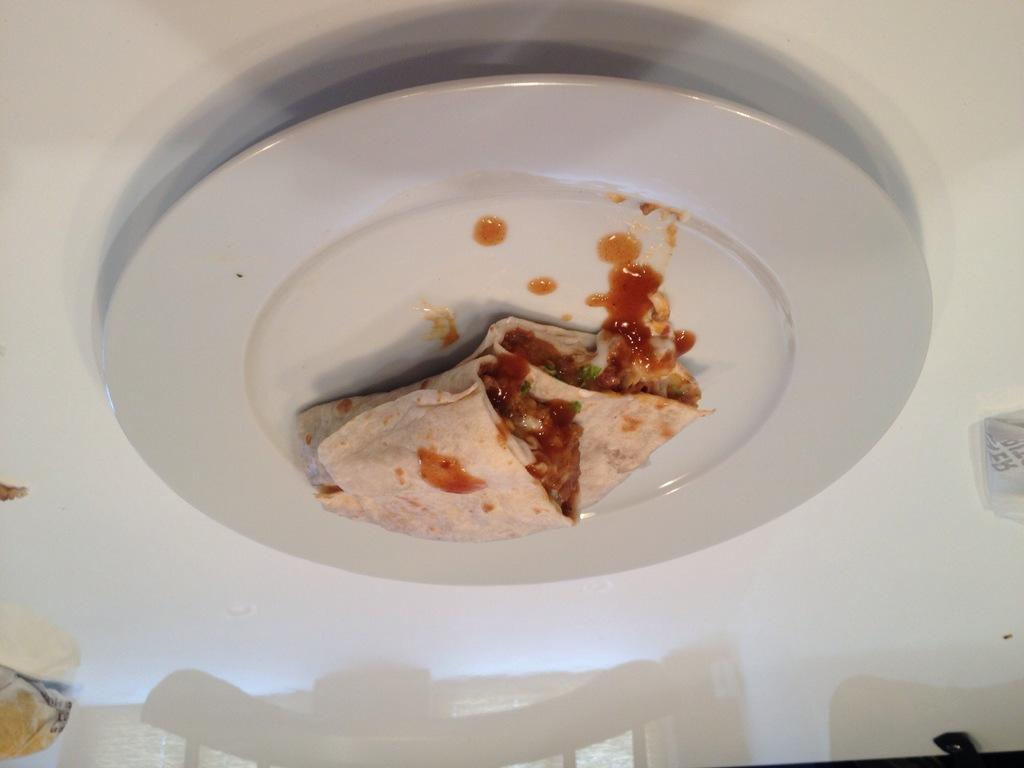What piece of furniture is visible in the image? There is a table in the image. What is placed on the table? There is a plate on the table. What is on the plate? There is food present in the plate. How many toes can be seen under the table in the image? There is no indication of toes or feet visible in the image. 